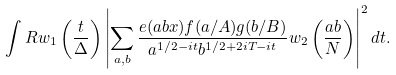Convert formula to latex. <formula><loc_0><loc_0><loc_500><loc_500>\int R w _ { 1 } \left ( \frac { t } { \Delta } \right ) \left | \sum _ { a , b } \frac { e ( a b x ) f ( a / A ) g ( b / B ) } { a ^ { 1 / 2 - i t } b ^ { 1 / 2 + 2 i T - i t } } w _ { 2 } \left ( \frac { a b } { N } \right ) \right | ^ { 2 } d t .</formula> 